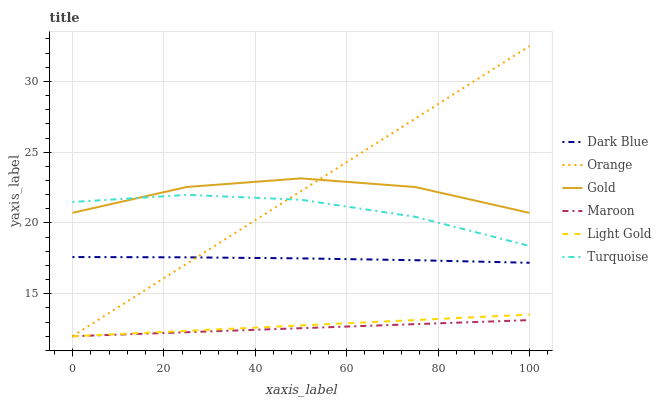Does Maroon have the minimum area under the curve?
Answer yes or no. Yes. Does Orange have the maximum area under the curve?
Answer yes or no. Yes. Does Gold have the minimum area under the curve?
Answer yes or no. No. Does Gold have the maximum area under the curve?
Answer yes or no. No. Is Maroon the smoothest?
Answer yes or no. Yes. Is Gold the roughest?
Answer yes or no. Yes. Is Gold the smoothest?
Answer yes or no. No. Is Maroon the roughest?
Answer yes or no. No. Does Maroon have the lowest value?
Answer yes or no. Yes. Does Gold have the lowest value?
Answer yes or no. No. Does Orange have the highest value?
Answer yes or no. Yes. Does Gold have the highest value?
Answer yes or no. No. Is Light Gold less than Dark Blue?
Answer yes or no. Yes. Is Turquoise greater than Maroon?
Answer yes or no. Yes. Does Orange intersect Maroon?
Answer yes or no. Yes. Is Orange less than Maroon?
Answer yes or no. No. Is Orange greater than Maroon?
Answer yes or no. No. Does Light Gold intersect Dark Blue?
Answer yes or no. No. 